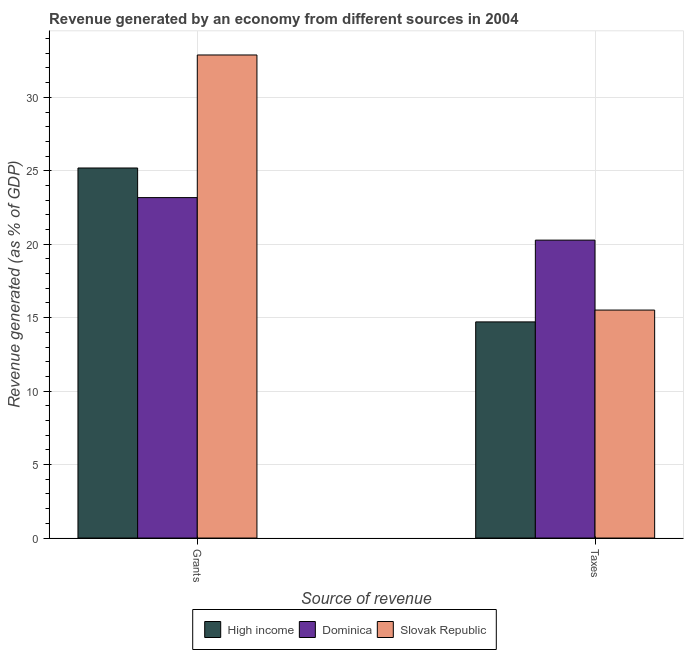How many different coloured bars are there?
Give a very brief answer. 3. Are the number of bars per tick equal to the number of legend labels?
Provide a succinct answer. Yes. What is the label of the 2nd group of bars from the left?
Your response must be concise. Taxes. What is the revenue generated by taxes in Dominica?
Ensure brevity in your answer.  20.28. Across all countries, what is the maximum revenue generated by taxes?
Keep it short and to the point. 20.28. Across all countries, what is the minimum revenue generated by grants?
Ensure brevity in your answer.  23.17. In which country was the revenue generated by grants maximum?
Provide a succinct answer. Slovak Republic. What is the total revenue generated by grants in the graph?
Make the answer very short. 81.25. What is the difference between the revenue generated by grants in Slovak Republic and that in Dominica?
Provide a short and direct response. 9.71. What is the difference between the revenue generated by grants in Slovak Republic and the revenue generated by taxes in Dominica?
Ensure brevity in your answer.  12.6. What is the average revenue generated by taxes per country?
Offer a very short reply. 16.84. What is the difference between the revenue generated by grants and revenue generated by taxes in Dominica?
Offer a terse response. 2.9. What is the ratio of the revenue generated by taxes in Dominica to that in Slovak Republic?
Provide a succinct answer. 1.31. Is the revenue generated by grants in High income less than that in Dominica?
Your answer should be very brief. No. What does the 1st bar from the left in Taxes represents?
Keep it short and to the point. High income. What does the 1st bar from the right in Grants represents?
Offer a terse response. Slovak Republic. How many bars are there?
Make the answer very short. 6. Are all the bars in the graph horizontal?
Give a very brief answer. No. What is the difference between two consecutive major ticks on the Y-axis?
Give a very brief answer. 5. Are the values on the major ticks of Y-axis written in scientific E-notation?
Your answer should be compact. No. Does the graph contain grids?
Keep it short and to the point. Yes. How many legend labels are there?
Keep it short and to the point. 3. How are the legend labels stacked?
Offer a terse response. Horizontal. What is the title of the graph?
Provide a succinct answer. Revenue generated by an economy from different sources in 2004. What is the label or title of the X-axis?
Keep it short and to the point. Source of revenue. What is the label or title of the Y-axis?
Give a very brief answer. Revenue generated (as % of GDP). What is the Revenue generated (as % of GDP) in High income in Grants?
Keep it short and to the point. 25.19. What is the Revenue generated (as % of GDP) in Dominica in Grants?
Ensure brevity in your answer.  23.17. What is the Revenue generated (as % of GDP) of Slovak Republic in Grants?
Give a very brief answer. 32.88. What is the Revenue generated (as % of GDP) of High income in Taxes?
Your answer should be compact. 14.71. What is the Revenue generated (as % of GDP) in Dominica in Taxes?
Keep it short and to the point. 20.28. What is the Revenue generated (as % of GDP) in Slovak Republic in Taxes?
Offer a terse response. 15.52. Across all Source of revenue, what is the maximum Revenue generated (as % of GDP) of High income?
Keep it short and to the point. 25.19. Across all Source of revenue, what is the maximum Revenue generated (as % of GDP) of Dominica?
Offer a terse response. 23.17. Across all Source of revenue, what is the maximum Revenue generated (as % of GDP) of Slovak Republic?
Offer a terse response. 32.88. Across all Source of revenue, what is the minimum Revenue generated (as % of GDP) in High income?
Offer a very short reply. 14.71. Across all Source of revenue, what is the minimum Revenue generated (as % of GDP) of Dominica?
Provide a succinct answer. 20.28. Across all Source of revenue, what is the minimum Revenue generated (as % of GDP) of Slovak Republic?
Keep it short and to the point. 15.52. What is the total Revenue generated (as % of GDP) of High income in the graph?
Make the answer very short. 39.9. What is the total Revenue generated (as % of GDP) in Dominica in the graph?
Keep it short and to the point. 43.45. What is the total Revenue generated (as % of GDP) in Slovak Republic in the graph?
Offer a very short reply. 48.4. What is the difference between the Revenue generated (as % of GDP) of High income in Grants and that in Taxes?
Your answer should be compact. 10.48. What is the difference between the Revenue generated (as % of GDP) in Dominica in Grants and that in Taxes?
Your response must be concise. 2.9. What is the difference between the Revenue generated (as % of GDP) in Slovak Republic in Grants and that in Taxes?
Provide a short and direct response. 17.36. What is the difference between the Revenue generated (as % of GDP) of High income in Grants and the Revenue generated (as % of GDP) of Dominica in Taxes?
Your response must be concise. 4.91. What is the difference between the Revenue generated (as % of GDP) in High income in Grants and the Revenue generated (as % of GDP) in Slovak Republic in Taxes?
Your answer should be compact. 9.67. What is the difference between the Revenue generated (as % of GDP) in Dominica in Grants and the Revenue generated (as % of GDP) in Slovak Republic in Taxes?
Make the answer very short. 7.66. What is the average Revenue generated (as % of GDP) of High income per Source of revenue?
Provide a short and direct response. 19.95. What is the average Revenue generated (as % of GDP) of Dominica per Source of revenue?
Provide a succinct answer. 21.73. What is the average Revenue generated (as % of GDP) in Slovak Republic per Source of revenue?
Your answer should be compact. 24.2. What is the difference between the Revenue generated (as % of GDP) of High income and Revenue generated (as % of GDP) of Dominica in Grants?
Give a very brief answer. 2.02. What is the difference between the Revenue generated (as % of GDP) in High income and Revenue generated (as % of GDP) in Slovak Republic in Grants?
Ensure brevity in your answer.  -7.69. What is the difference between the Revenue generated (as % of GDP) of Dominica and Revenue generated (as % of GDP) of Slovak Republic in Grants?
Your answer should be very brief. -9.71. What is the difference between the Revenue generated (as % of GDP) in High income and Revenue generated (as % of GDP) in Dominica in Taxes?
Ensure brevity in your answer.  -5.57. What is the difference between the Revenue generated (as % of GDP) of High income and Revenue generated (as % of GDP) of Slovak Republic in Taxes?
Offer a terse response. -0.8. What is the difference between the Revenue generated (as % of GDP) in Dominica and Revenue generated (as % of GDP) in Slovak Republic in Taxes?
Provide a short and direct response. 4.76. What is the ratio of the Revenue generated (as % of GDP) in High income in Grants to that in Taxes?
Your response must be concise. 1.71. What is the ratio of the Revenue generated (as % of GDP) in Dominica in Grants to that in Taxes?
Your response must be concise. 1.14. What is the ratio of the Revenue generated (as % of GDP) in Slovak Republic in Grants to that in Taxes?
Provide a short and direct response. 2.12. What is the difference between the highest and the second highest Revenue generated (as % of GDP) in High income?
Offer a very short reply. 10.48. What is the difference between the highest and the second highest Revenue generated (as % of GDP) of Dominica?
Your answer should be compact. 2.9. What is the difference between the highest and the second highest Revenue generated (as % of GDP) of Slovak Republic?
Offer a terse response. 17.36. What is the difference between the highest and the lowest Revenue generated (as % of GDP) in High income?
Make the answer very short. 10.48. What is the difference between the highest and the lowest Revenue generated (as % of GDP) of Dominica?
Ensure brevity in your answer.  2.9. What is the difference between the highest and the lowest Revenue generated (as % of GDP) of Slovak Republic?
Ensure brevity in your answer.  17.36. 